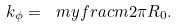<formula> <loc_0><loc_0><loc_500><loc_500>k _ { \phi } = \ m y f r a c { m } { 2 \pi R _ { 0 } } .</formula> 